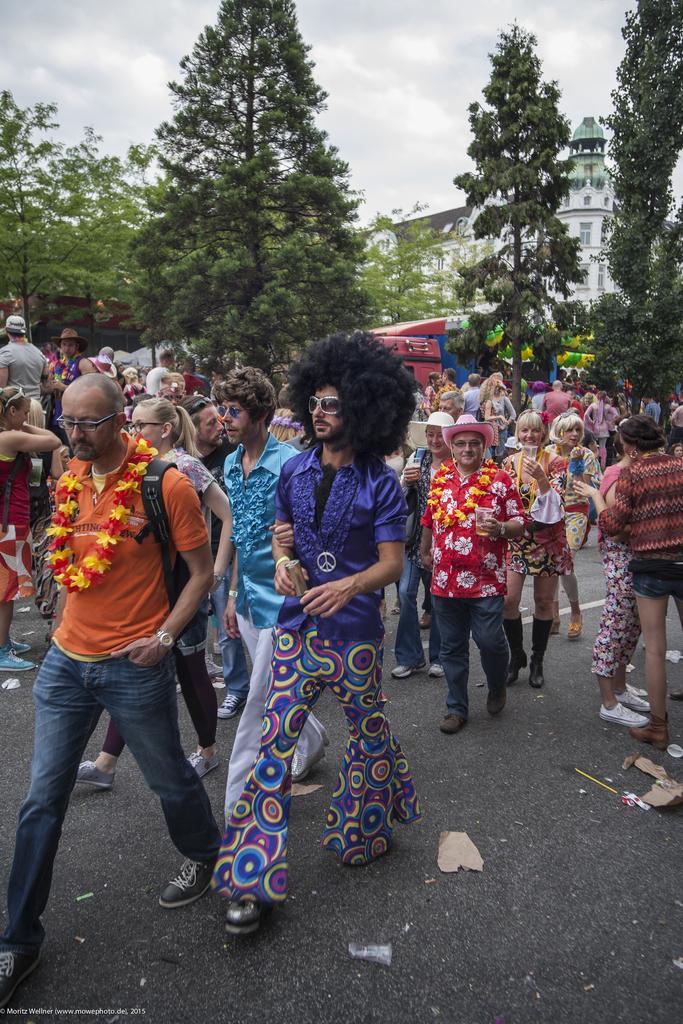Could you give a brief overview of what you see in this image? In this picture we can see some people are on the road, among them few people are holding objects in hand, behind we can see some buildings, trees. 